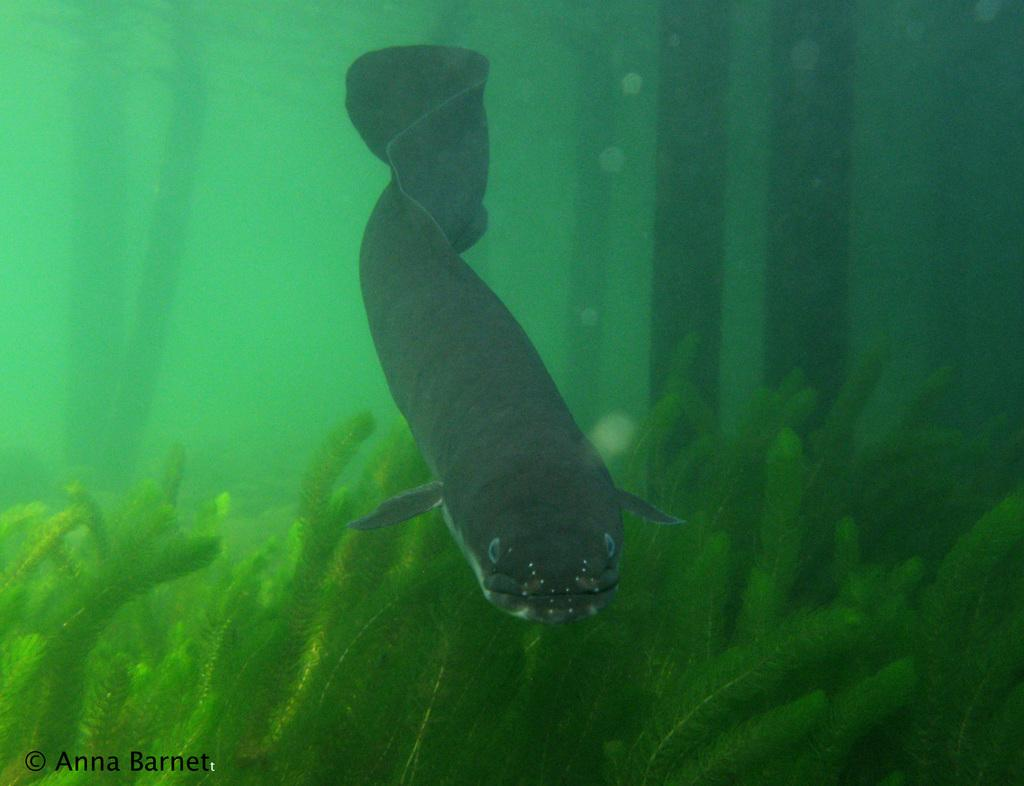Where was the image taken? The image is taken in the sea. What can be seen at the bottom of the image? There are coral reefs at the bottom of the image. Are the coral reefs in the water or on land? The coral reefs are in the water. What is the main subject in the middle of the image? There is a fish in the middle of the image. Is the fish also in the water? Yes, the fish is in the water. What suggestion does the fish give to the coral reefs in the image? There is no suggestion given by the fish to the coral reefs in the image, as fish do not communicate in this way. 